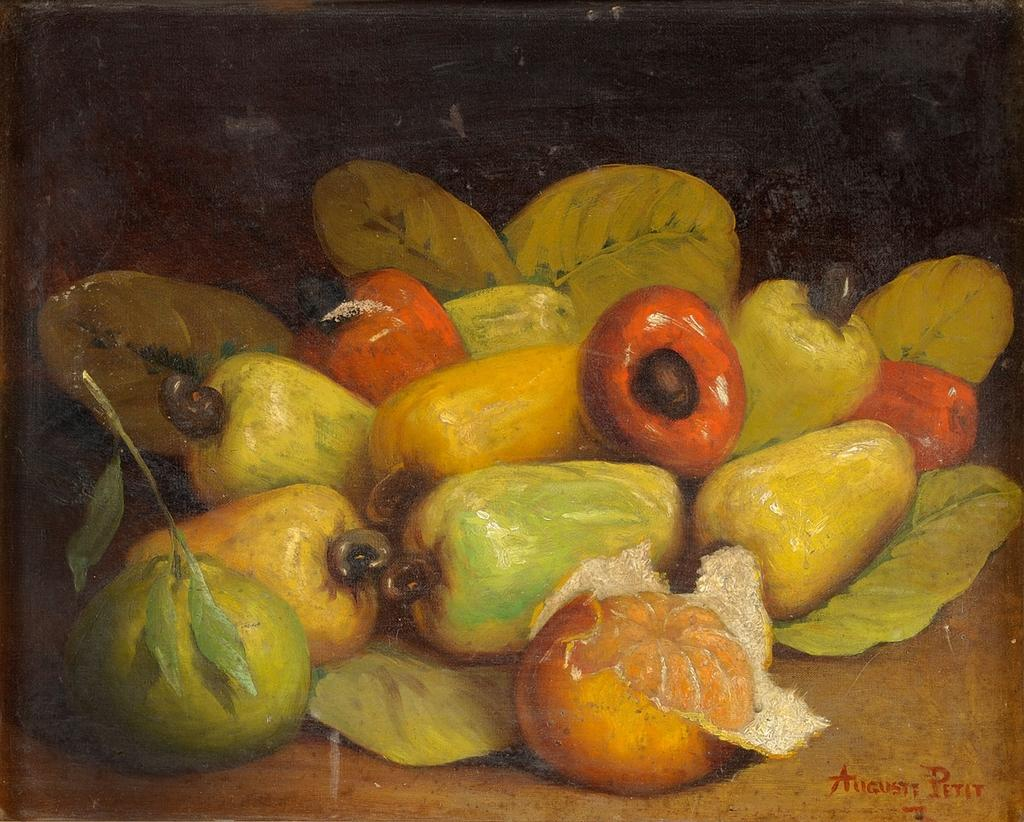What is the main subject of the painting in the image? The main subject of the painting in the image is fruits. Where is the text located in the image? The text is located at the right bottom of the image. What type of door is depicted in the painting of fruits? There is no door depicted in the painting of fruits; the painting only features fruits. 